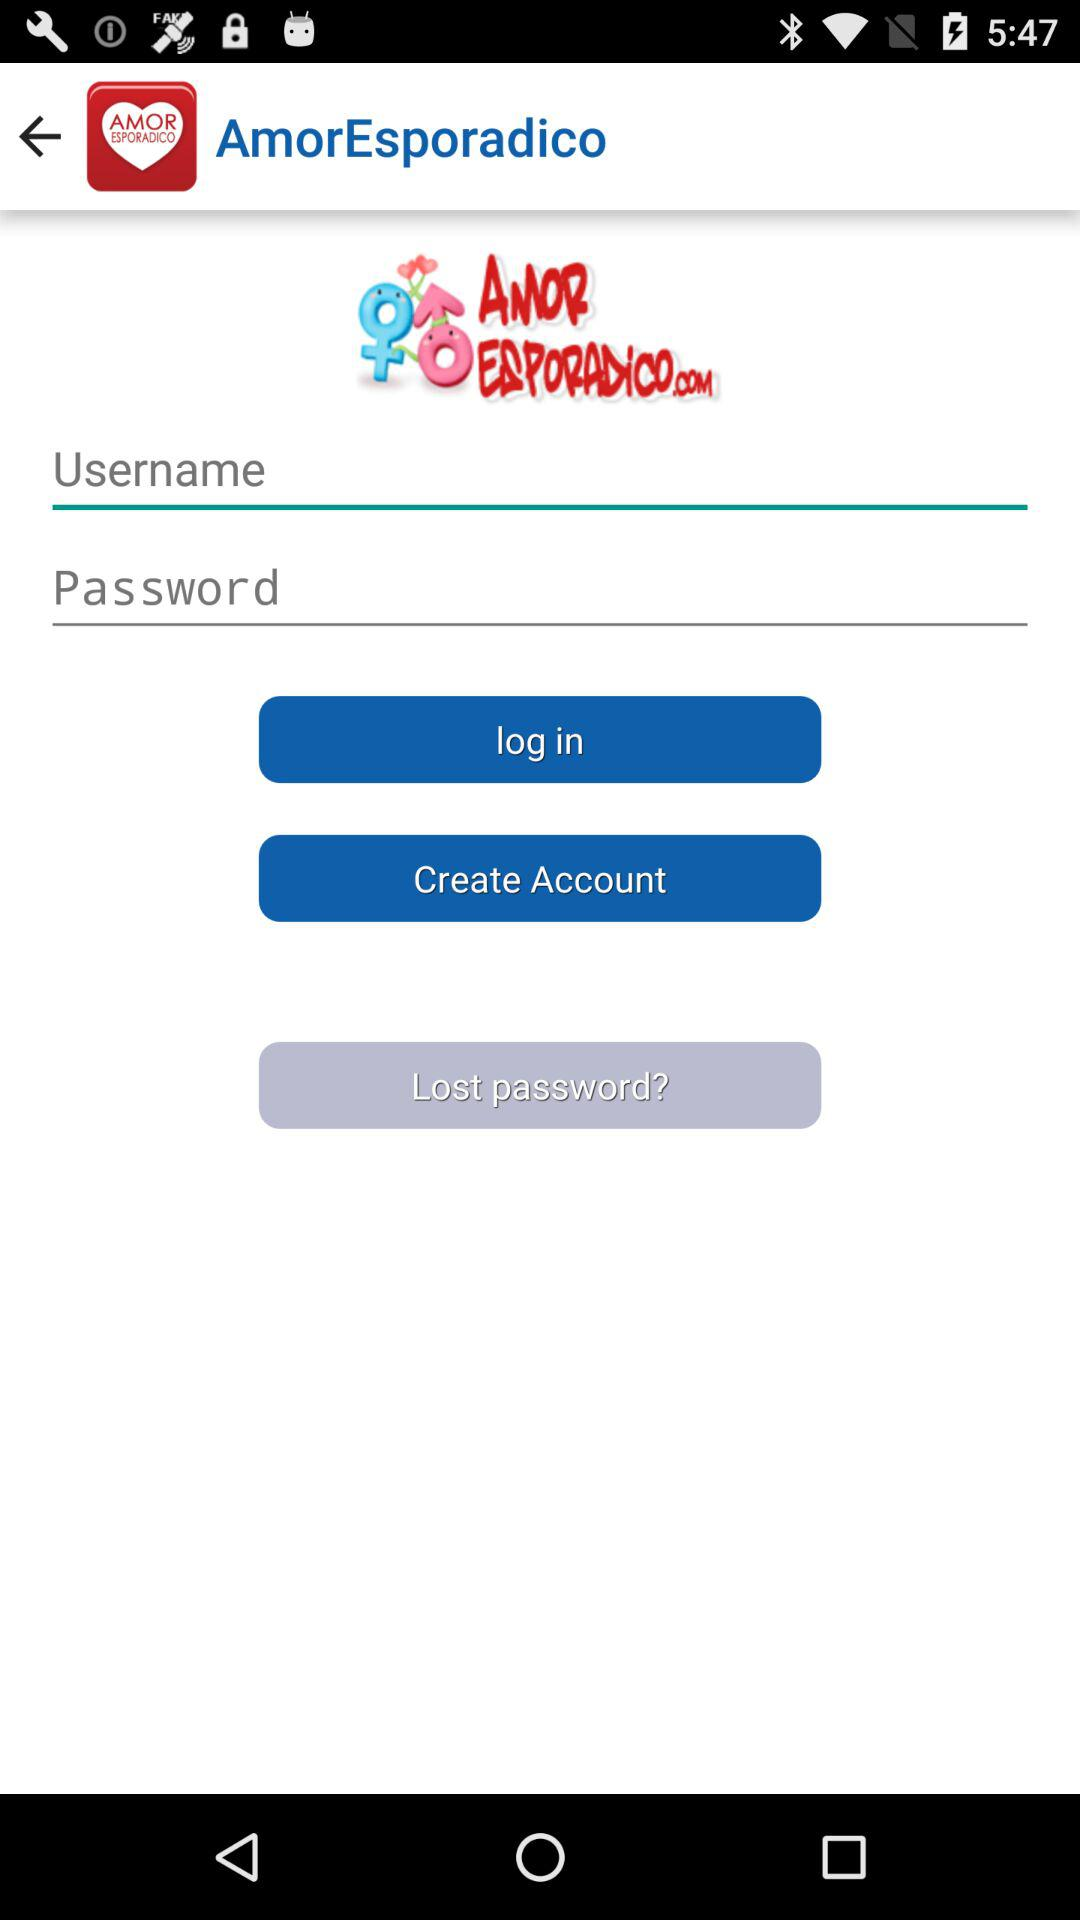What is the application name? The application name is "AmorEsporadico". 